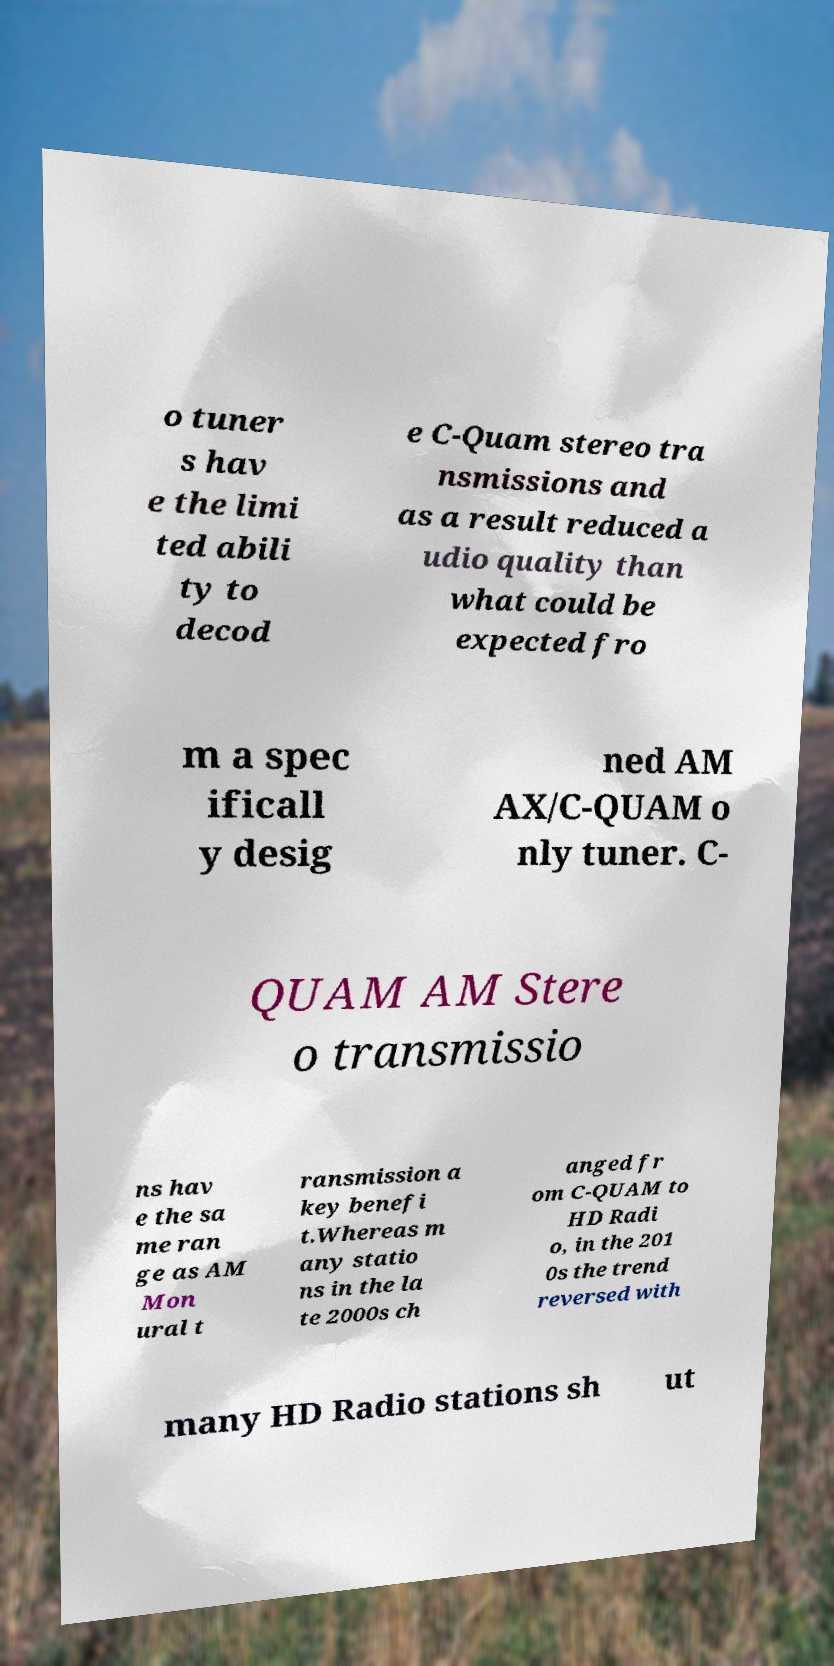Can you read and provide the text displayed in the image?This photo seems to have some interesting text. Can you extract and type it out for me? o tuner s hav e the limi ted abili ty to decod e C-Quam stereo tra nsmissions and as a result reduced a udio quality than what could be expected fro m a spec ificall y desig ned AM AX/C-QUAM o nly tuner. C- QUAM AM Stere o transmissio ns hav e the sa me ran ge as AM Mon ural t ransmission a key benefi t.Whereas m any statio ns in the la te 2000s ch anged fr om C-QUAM to HD Radi o, in the 201 0s the trend reversed with many HD Radio stations sh ut 